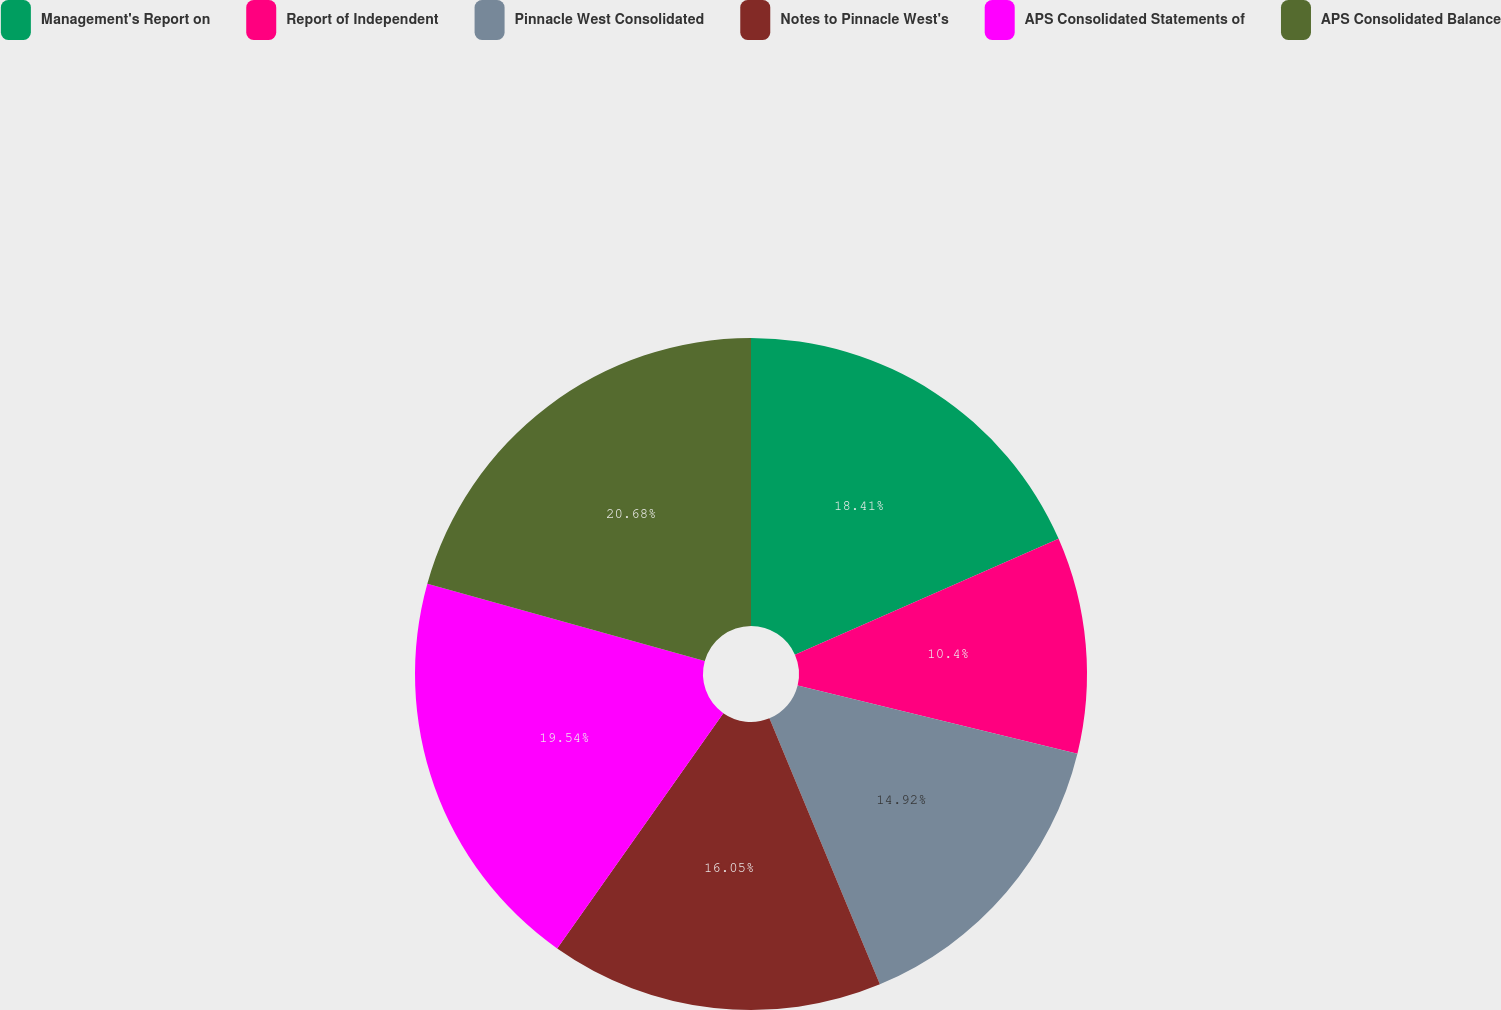Convert chart to OTSL. <chart><loc_0><loc_0><loc_500><loc_500><pie_chart><fcel>Management's Report on<fcel>Report of Independent<fcel>Pinnacle West Consolidated<fcel>Notes to Pinnacle West's<fcel>APS Consolidated Statements of<fcel>APS Consolidated Balance<nl><fcel>18.41%<fcel>10.4%<fcel>14.92%<fcel>16.05%<fcel>19.54%<fcel>20.67%<nl></chart> 